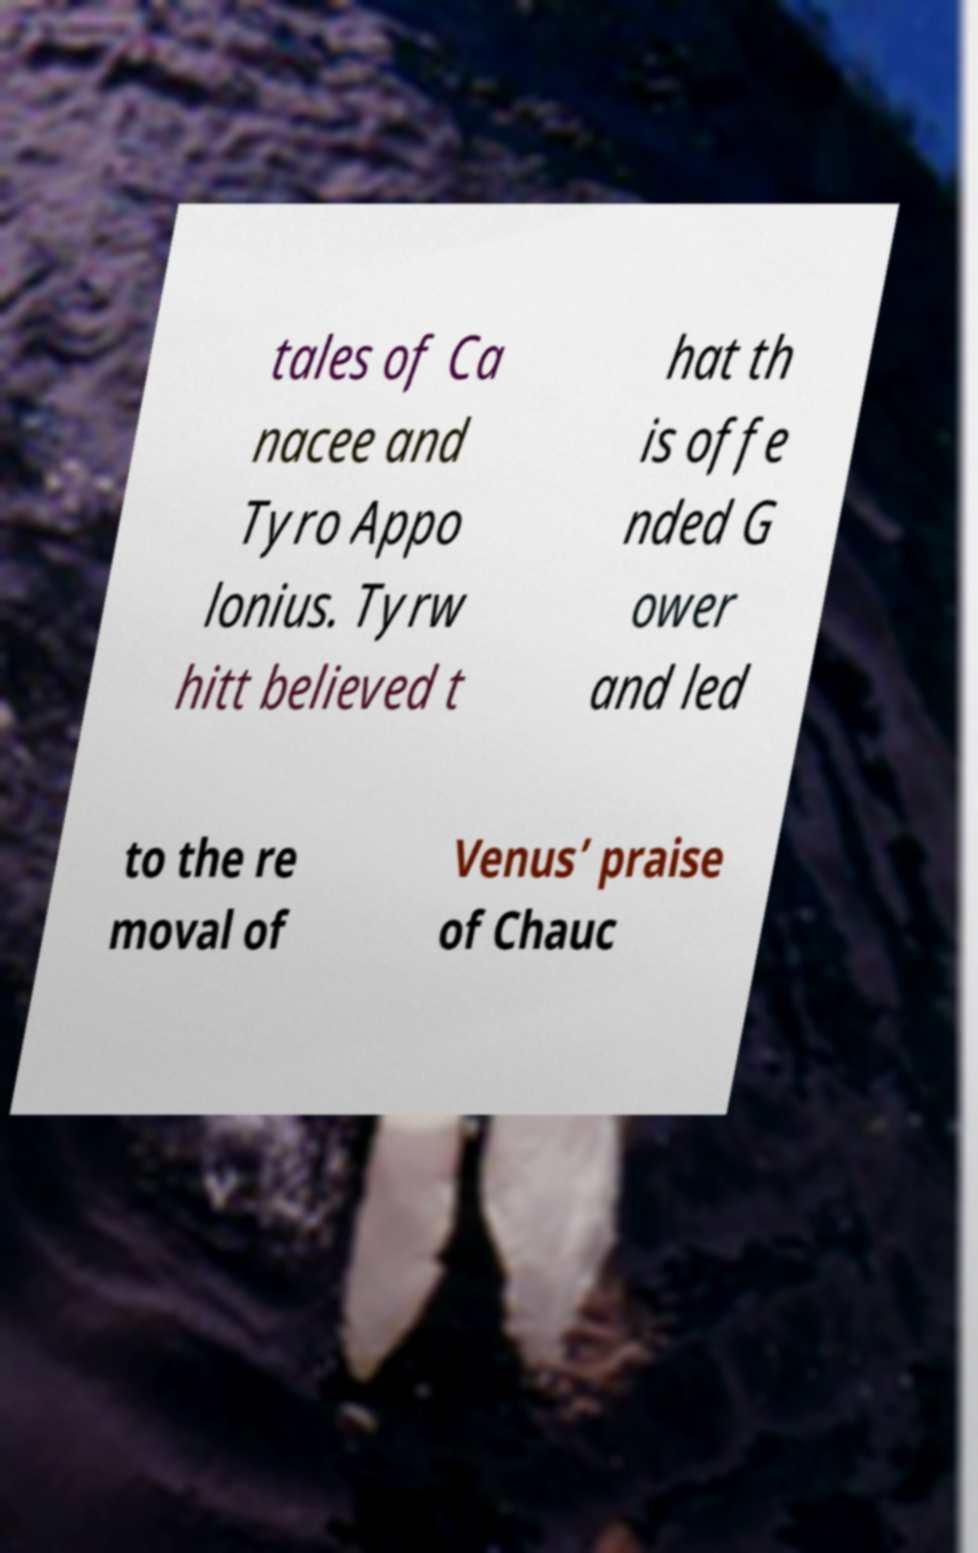I need the written content from this picture converted into text. Can you do that? tales of Ca nacee and Tyro Appo lonius. Tyrw hitt believed t hat th is offe nded G ower and led to the re moval of Venus’ praise of Chauc 